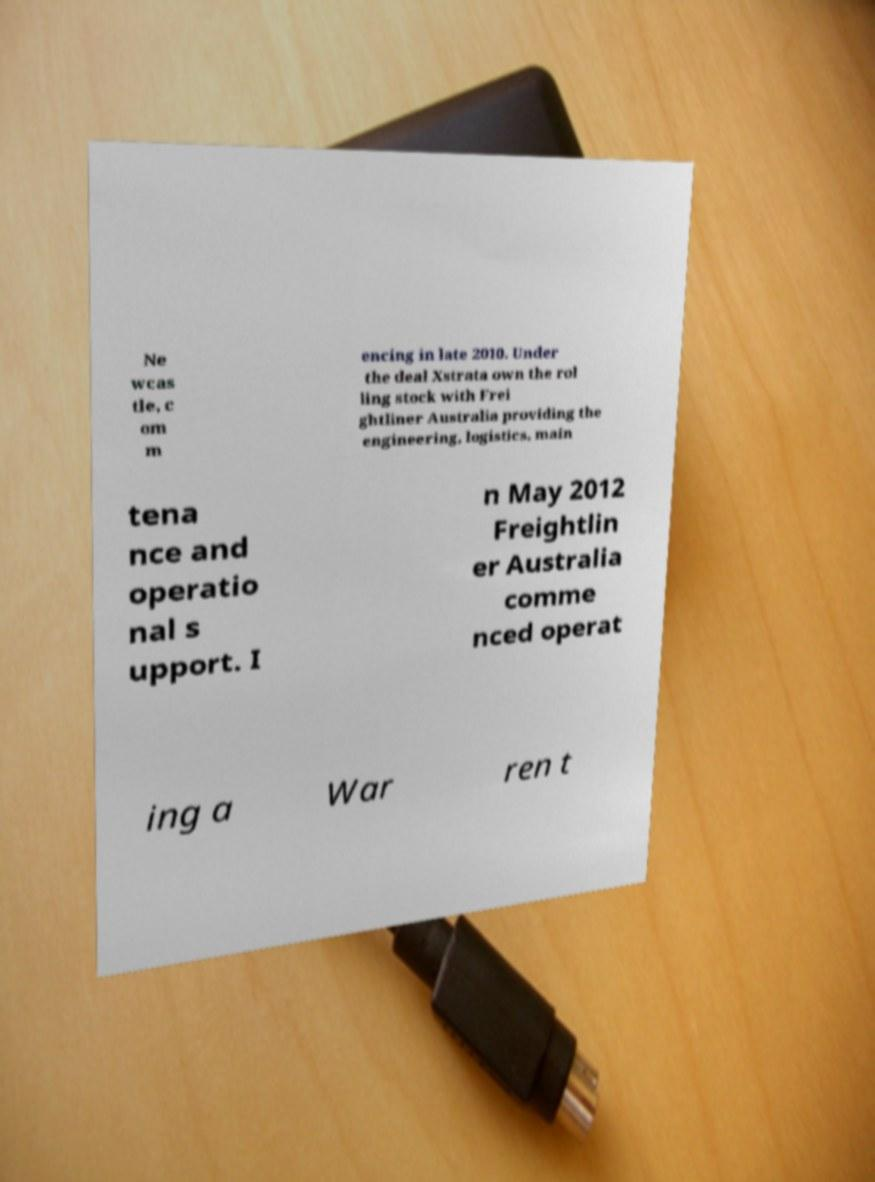Can you accurately transcribe the text from the provided image for me? Ne wcas tle, c om m encing in late 2010. Under the deal Xstrata own the rol ling stock with Frei ghtliner Australia providing the engineering, logistics, main tena nce and operatio nal s upport. I n May 2012 Freightlin er Australia comme nced operat ing a War ren t 